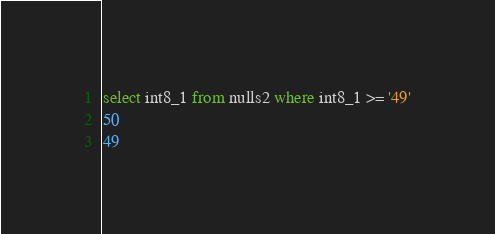Convert code to text. <code><loc_0><loc_0><loc_500><loc_500><_SQL_>select int8_1 from nulls2 where int8_1 >= '49'
50
49
</code> 